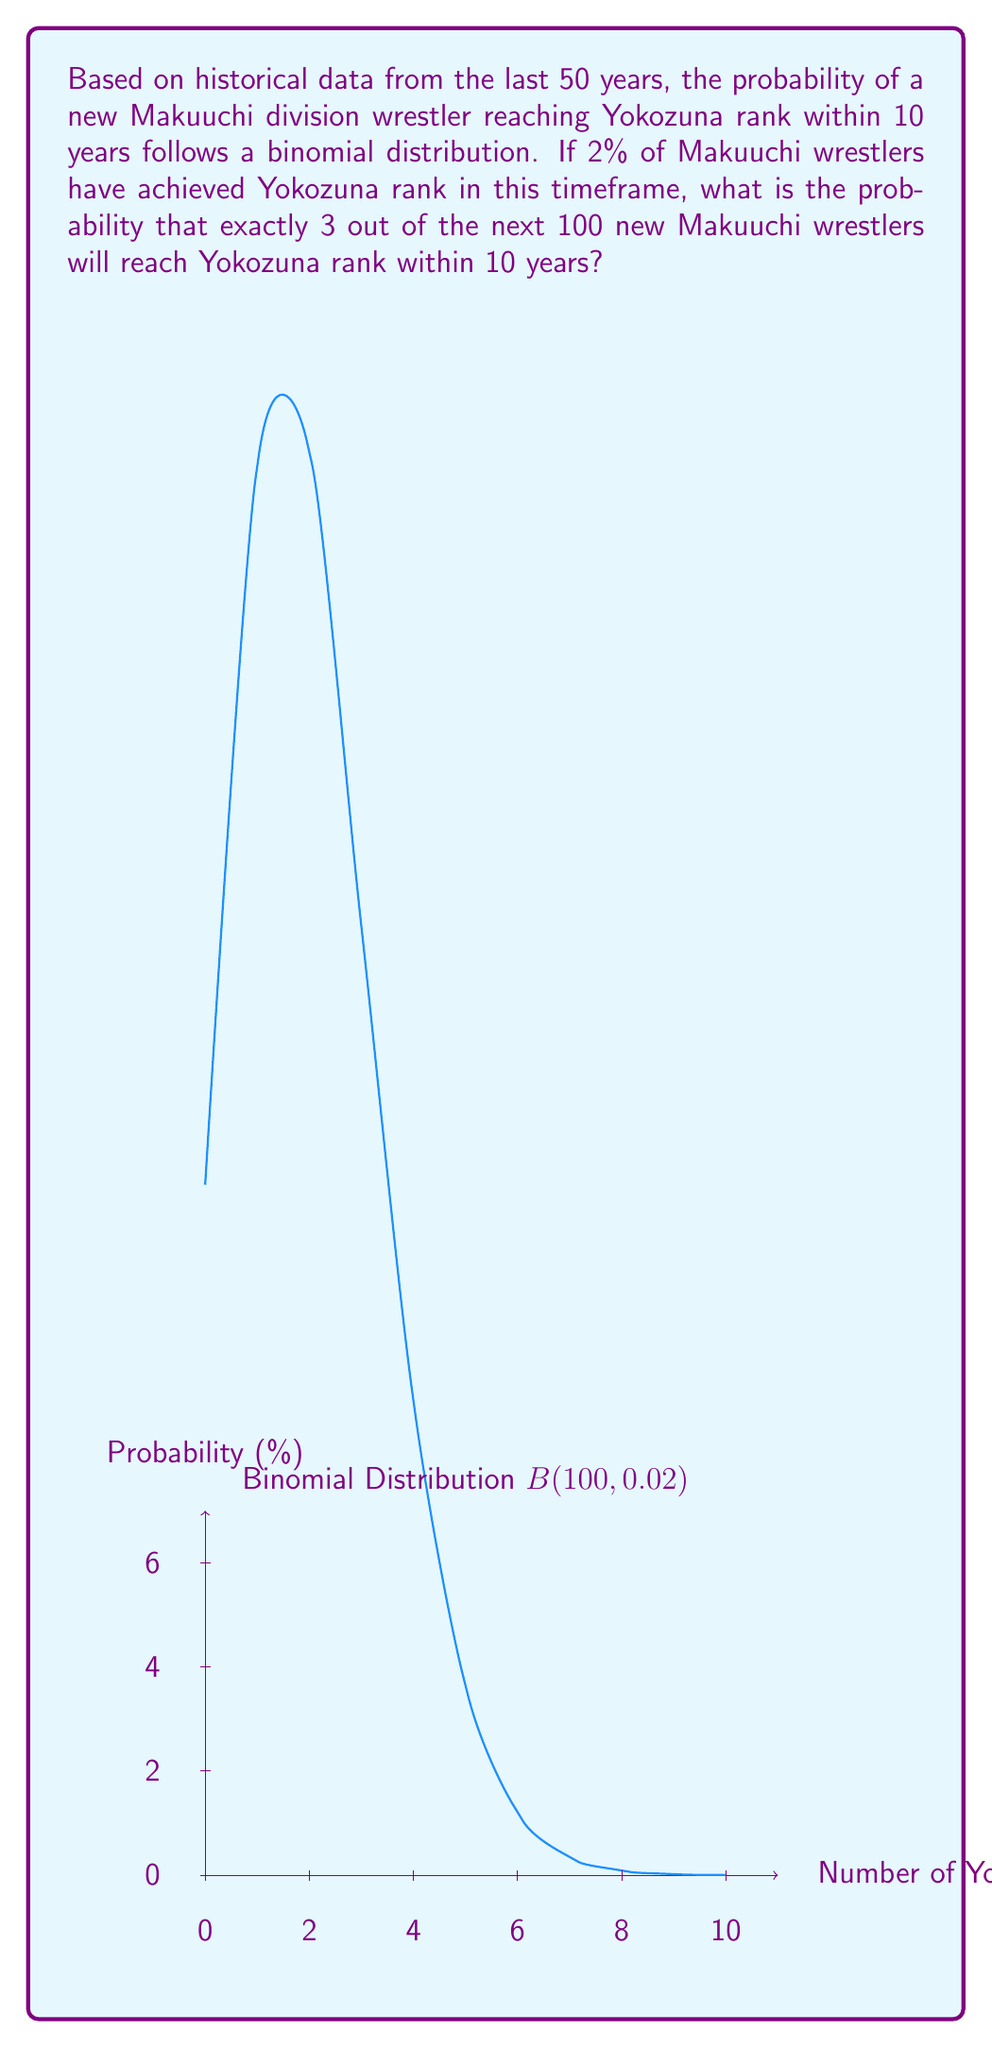Help me with this question. Let's approach this step-by-step using the binomial probability distribution:

1) We have a binomial distribution with parameters:
   $n = 100$ (number of trials)
   $p = 0.02$ (probability of success on each trial)
   $k = 3$ (number of successes we're interested in)

2) The probability mass function for a binomial distribution is:

   $P(X = k) = \binom{n}{k} p^k (1-p)^{n-k}$

3) Let's calculate each part:

   a) $\binom{n}{k} = \binom{100}{3} = \frac{100!}{3!(100-3)!} = 161700$

   b) $p^k = 0.02^3 = 0.000008$

   c) $(1-p)^{n-k} = 0.98^{97} \approx 0.1431$

4) Now, let's put it all together:

   $P(X = 3) = 161700 \times 0.000008 \times 0.1431$

5) Calculate the final result:

   $P(X = 3) \approx 0.1853$ or about $18.53\%$

Therefore, the probability that exactly 3 out of the next 100 new Makuuchi wrestlers will reach Yokozuna rank within 10 years is approximately 0.1853 or 18.53%.
Answer: $0.1853$ or $18.53\%$ 